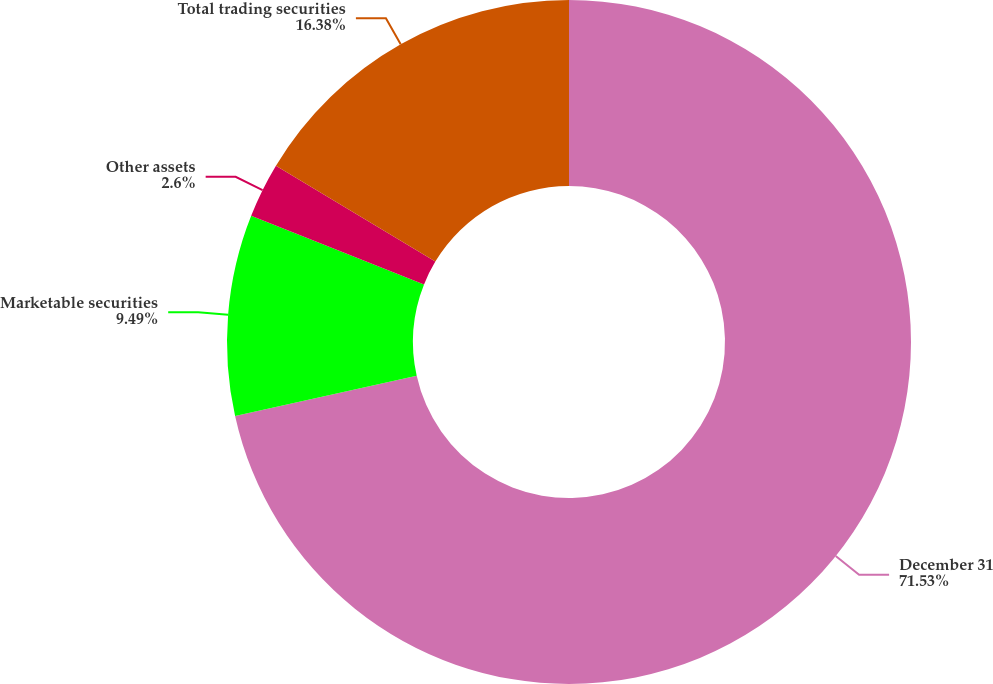Convert chart to OTSL. <chart><loc_0><loc_0><loc_500><loc_500><pie_chart><fcel>December 31<fcel>Marketable securities<fcel>Other assets<fcel>Total trading securities<nl><fcel>71.53%<fcel>9.49%<fcel>2.6%<fcel>16.38%<nl></chart> 